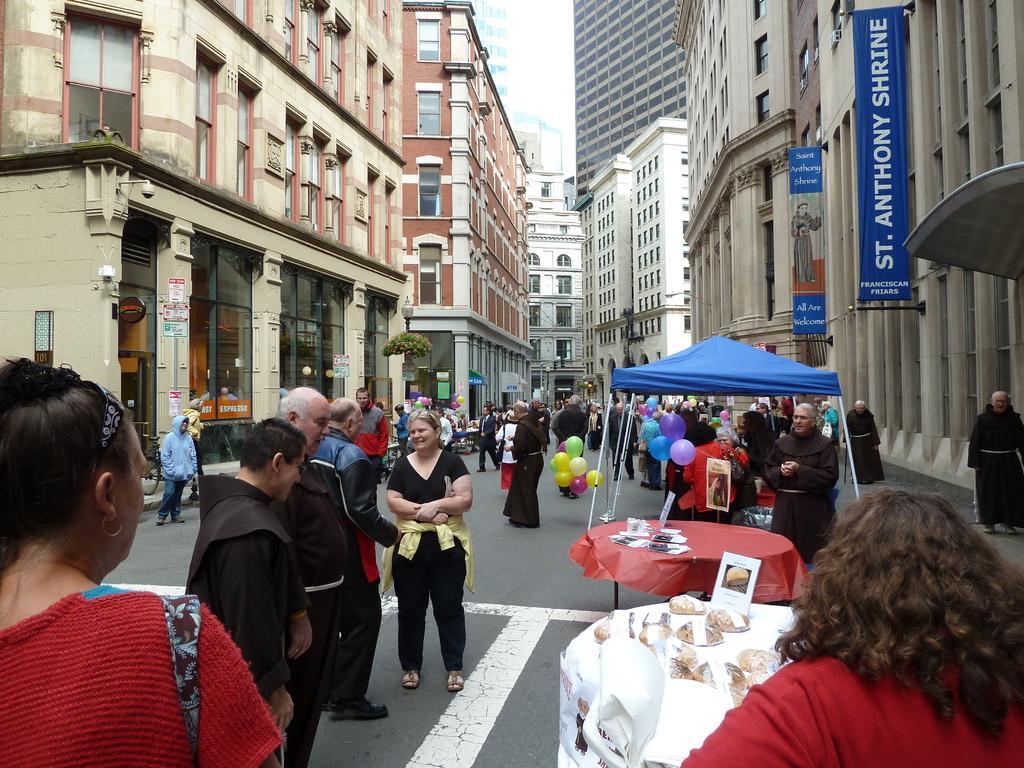Please provide a concise description of this image. There are groups of people standing. These are the colorful balloons. I can see the buildings with the windows and glass doors. This looks like a small tree. These are the banners hanging. I think this is a canopy tent. I can see two tables covered with the clothes. There are few objects placed on the tables. 